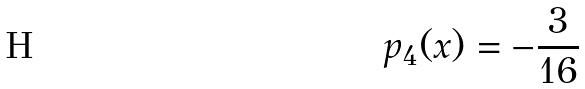Convert formula to latex. <formula><loc_0><loc_0><loc_500><loc_500>p _ { 4 } ( x ) = - \frac { 3 } { 1 6 }</formula> 